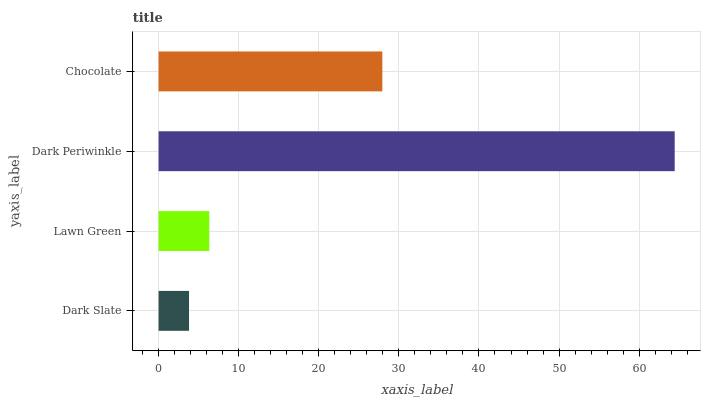Is Dark Slate the minimum?
Answer yes or no. Yes. Is Dark Periwinkle the maximum?
Answer yes or no. Yes. Is Lawn Green the minimum?
Answer yes or no. No. Is Lawn Green the maximum?
Answer yes or no. No. Is Lawn Green greater than Dark Slate?
Answer yes or no. Yes. Is Dark Slate less than Lawn Green?
Answer yes or no. Yes. Is Dark Slate greater than Lawn Green?
Answer yes or no. No. Is Lawn Green less than Dark Slate?
Answer yes or no. No. Is Chocolate the high median?
Answer yes or no. Yes. Is Lawn Green the low median?
Answer yes or no. Yes. Is Dark Periwinkle the high median?
Answer yes or no. No. Is Dark Slate the low median?
Answer yes or no. No. 